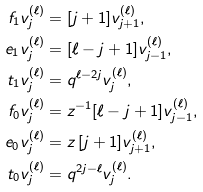Convert formula to latex. <formula><loc_0><loc_0><loc_500><loc_500>f _ { 1 } v _ { j } ^ { ( \ell ) } & = [ j + 1 ] v _ { j + 1 } ^ { ( \ell ) } , \\ e _ { 1 } v _ { j } ^ { ( \ell ) } & = [ \ell - j + 1 ] v _ { j - 1 } ^ { ( \ell ) } , \\ t _ { 1 } v _ { j } ^ { ( \ell ) } & = q ^ { \ell - 2 j } v _ { j } ^ { ( \ell ) } , \\ f _ { 0 } v _ { j } ^ { ( \ell ) } & = z ^ { - 1 } [ \ell - j + 1 ] v _ { j - 1 } ^ { ( \ell ) } , \\ e _ { 0 } v _ { j } ^ { ( \ell ) } & = z \, [ j + 1 ] v _ { j + 1 } ^ { ( \ell ) } , \\ t _ { 0 } v _ { j } ^ { ( \ell ) } & = q ^ { 2 j - \ell } v _ { j } ^ { ( \ell ) } .</formula> 